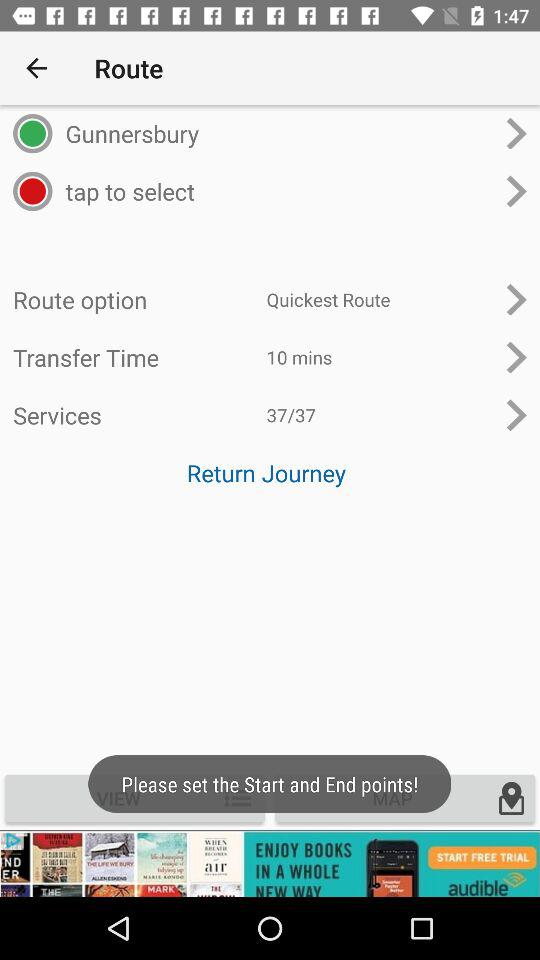Which is the selected route option? The selected route option is "Quickest Route". 